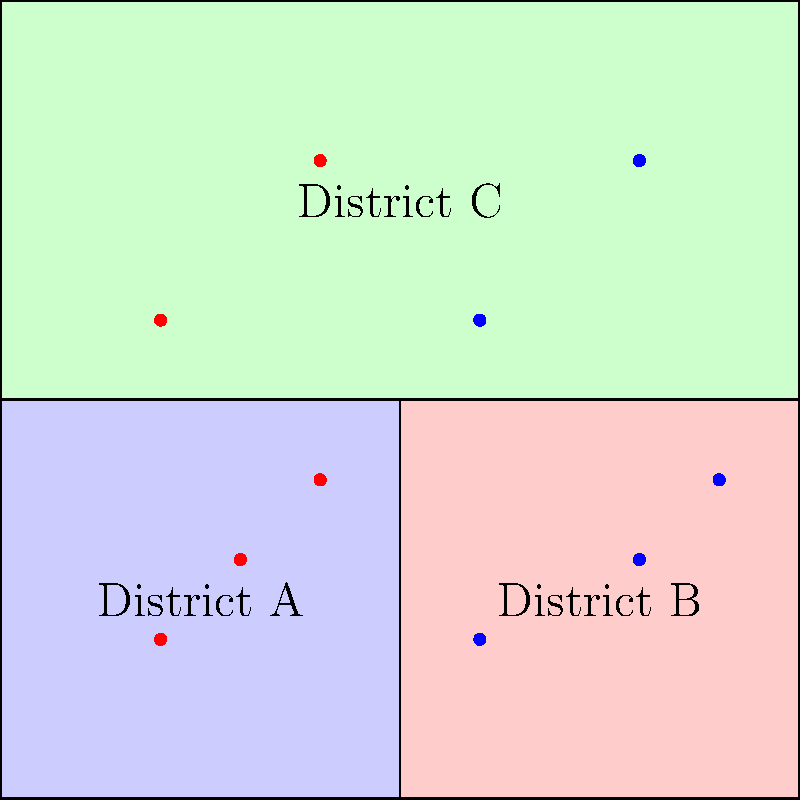In the voting district map shown above, red dots represent voters for Party X and blue dots represent voters for Party Y. Given this distribution of voters, which party is likely to win the most districts, and how does this relate to the concept of gerrymandering? To analyze this situation, let's follow these steps:

1. Count the voters in each district:
   - District A: 3 red, 0 blue
   - District B: 0 red, 3 blue
   - District C: 2 red, 2 blue

2. Determine the winner of each district:
   - District A: Party X wins
   - District B: Party Y wins
   - District C: Tie (for simplicity, let's assume Party Y wins in a tiebreaker)

3. Count the total number of voters for each party:
   - Party X: 5 voters
   - Party Y: 5 voters

4. Compare the district wins to the popular vote:
   - Party Y wins 2 out of 3 districts (66.7%)
   - The popular vote is evenly split (50% each)

5. Relate to gerrymandering:
   Gerrymandering is the practice of manipulating district boundaries to favor one party over another. In this case, despite an even split in the popular vote, Party Y wins more districts. This is achieved by concentrating Party X voters in District A (known as "packing") and spreading Party Y voters across Districts B and C (known as "cracking").

6. Consider the impact:
   This district shape gives Party Y a disproportionate advantage in representation compared to their share of the popular vote, which is a key characteristic of gerrymandered districts.
Answer: Party Y likely wins more districts despite an even popular vote, demonstrating potential gerrymandering effects. 